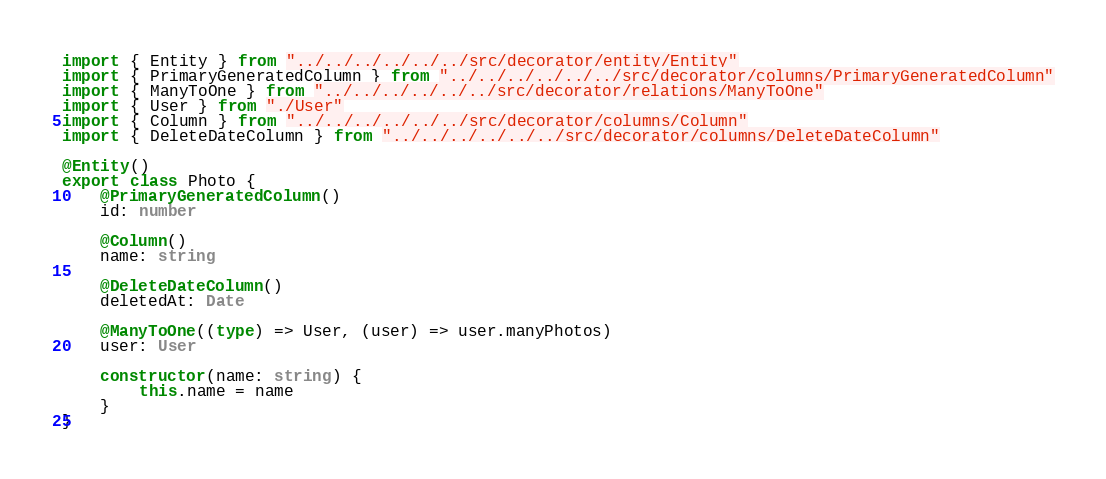<code> <loc_0><loc_0><loc_500><loc_500><_TypeScript_>import { Entity } from "../../../../../../src/decorator/entity/Entity"
import { PrimaryGeneratedColumn } from "../../../../../../src/decorator/columns/PrimaryGeneratedColumn"
import { ManyToOne } from "../../../../../../src/decorator/relations/ManyToOne"
import { User } from "./User"
import { Column } from "../../../../../../src/decorator/columns/Column"
import { DeleteDateColumn } from "../../../../../../src/decorator/columns/DeleteDateColumn"

@Entity()
export class Photo {
    @PrimaryGeneratedColumn()
    id: number

    @Column()
    name: string

    @DeleteDateColumn()
    deletedAt: Date

    @ManyToOne((type) => User, (user) => user.manyPhotos)
    user: User

    constructor(name: string) {
        this.name = name
    }
}
</code> 